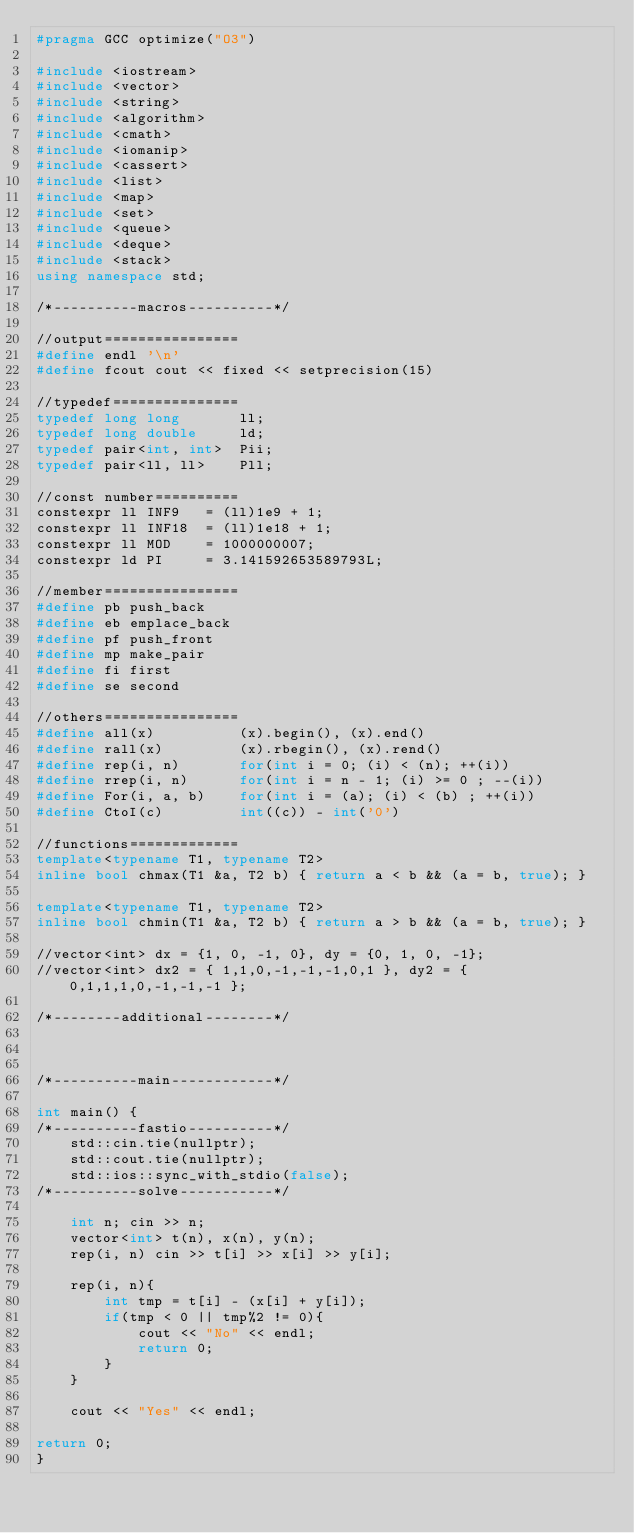Convert code to text. <code><loc_0><loc_0><loc_500><loc_500><_C++_>#pragma GCC optimize("O3")

#include <iostream>
#include <vector>
#include <string>
#include <algorithm>
#include <cmath>
#include <iomanip>
#include <cassert>
#include <list>
#include <map>
#include <set>
#include <queue>
#include <deque>
#include <stack>
using namespace std;

/*----------macros----------*/

//output================
#define endl '\n'
#define fcout cout << fixed << setprecision(15)

//typedef===============
typedef long long       ll;
typedef long double     ld;
typedef pair<int, int>  Pii;
typedef pair<ll, ll>    Pll;

//const number==========
constexpr ll INF9   = (ll)1e9 + 1;
constexpr ll INF18  = (ll)1e18 + 1;
constexpr ll MOD    = 1000000007;
constexpr ld PI     = 3.141592653589793L;

//member================
#define pb push_back
#define eb emplace_back
#define pf push_front
#define mp make_pair
#define fi first
#define se second

//others================
#define all(x)          (x).begin(), (x).end()
#define rall(x)         (x).rbegin(), (x).rend()
#define rep(i, n)       for(int i = 0; (i) < (n); ++(i))
#define rrep(i, n)      for(int i = n - 1; (i) >= 0 ; --(i))
#define For(i, a, b)    for(int i = (a); (i) < (b) ; ++(i))
#define CtoI(c)         int((c)) - int('0')

//functions=============
template<typename T1, typename T2>
inline bool chmax(T1 &a, T2 b) { return a < b && (a = b, true); }

template<typename T1, typename T2>
inline bool chmin(T1 &a, T2 b) { return a > b && (a = b, true); }

//vector<int> dx = {1, 0, -1, 0}, dy = {0, 1, 0, -1};
//vector<int> dx2 = { 1,1,0,-1,-1,-1,0,1 }, dy2 = { 0,1,1,1,0,-1,-1,-1 };

/*--------additional--------*/



/*----------main------------*/

int main() {
/*----------fastio----------*/
    std::cin.tie(nullptr);
    std::cout.tie(nullptr);
    std::ios::sync_with_stdio(false);
/*----------solve-----------*/

    int n; cin >> n;
    vector<int> t(n), x(n), y(n);
    rep(i, n) cin >> t[i] >> x[i] >> y[i];

    rep(i, n){
        int tmp = t[i] - (x[i] + y[i]);
        if(tmp < 0 || tmp%2 != 0){
            cout << "No" << endl;
            return 0;
        }
    }

    cout << "Yes" << endl;

return 0;
}</code> 